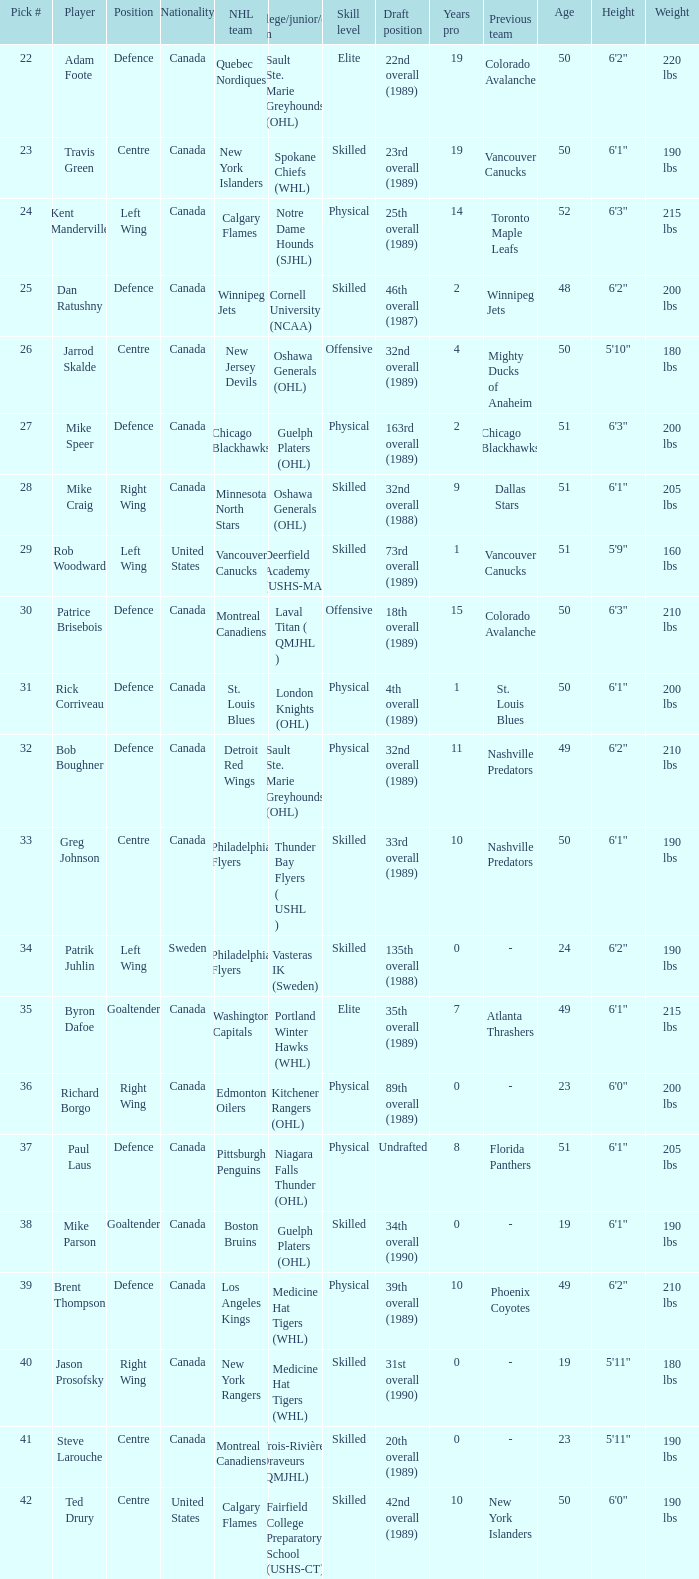To which nationality does the player selected for the washington capitals belong? Canada. 